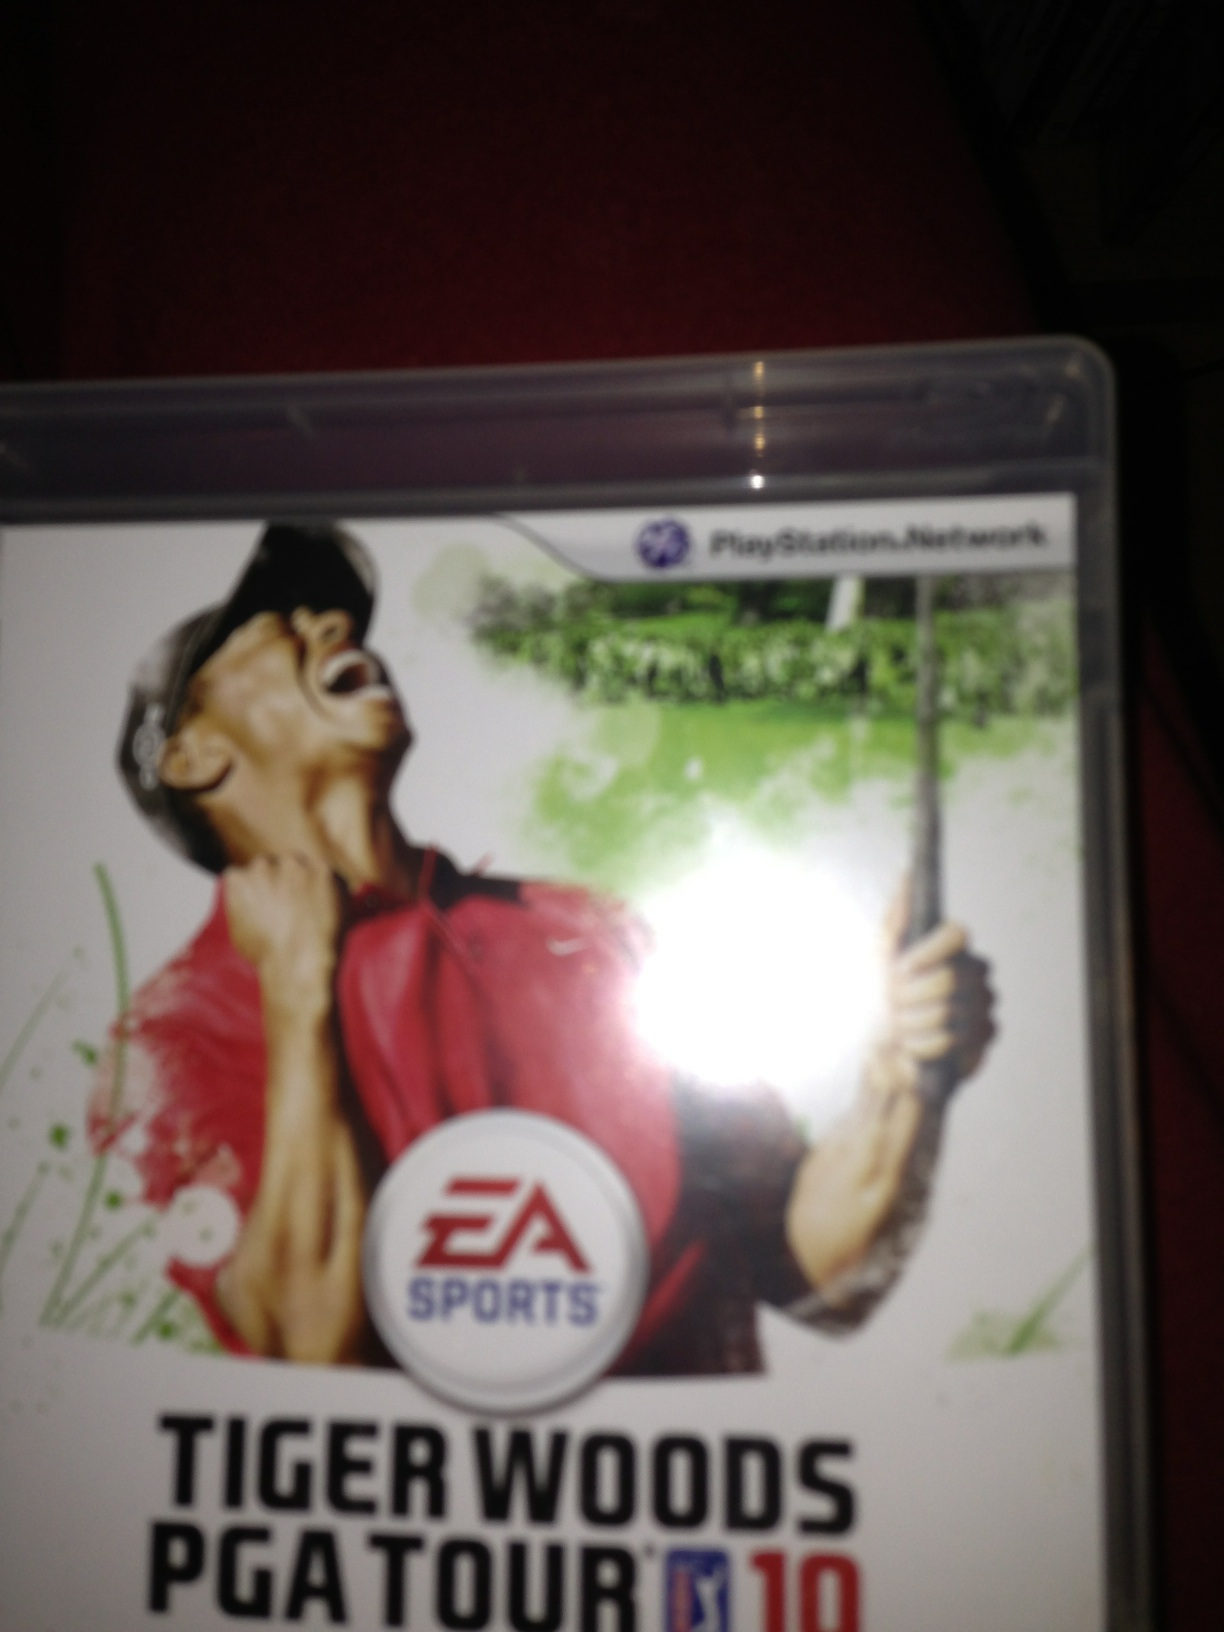What's the impact of The Weather Channel's real-time weather integration in the game? The integration of real-time weather from The Weather Channel in 'Tiger Woods PGA Tour 10' adds a significant layer of realism and unpredictability to the gameplay. It means that if it's raining or windy in real life, these conditions will be mirrored in the game, affecting how the ball behaves, the difficulty of shots, and overall strategy. This feature forces players to constantly adapt to changing conditions, making each game session unique and more challenging, closely mimicking real-life golfing scenarios. How long does it usually take to complete a typical game session? Completing a typical game session in 'Tiger Woods PGA Tour 10' can vary greatly depending on the chosen mode and the player's objectives. A single round of golf, consisting of all 18 holes, can take anywhere from 30 minutes to an hour depending on the player's pace. In contrast, completing a full tournament or engaging in career mode, where players progress through multiple rounds and events, can take several hours. The game also offers shorter challenges and mini-games that can be completed within 10-20 minutes, providing flexible options for different play durations. 